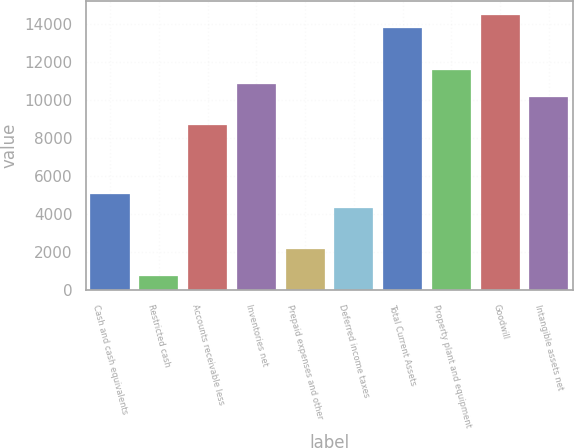Convert chart to OTSL. <chart><loc_0><loc_0><loc_500><loc_500><bar_chart><fcel>Cash and cash equivalents<fcel>Restricted cash<fcel>Accounts receivable less<fcel>Inventories net<fcel>Prepaid expenses and other<fcel>Deferred income taxes<fcel>Total Current Assets<fcel>Property plant and equipment<fcel>Goodwill<fcel>Intangible assets net<nl><fcel>5068.05<fcel>726.15<fcel>8686.3<fcel>10857.2<fcel>2173.45<fcel>4344.4<fcel>13751.9<fcel>11580.9<fcel>14475.5<fcel>10133.6<nl></chart> 